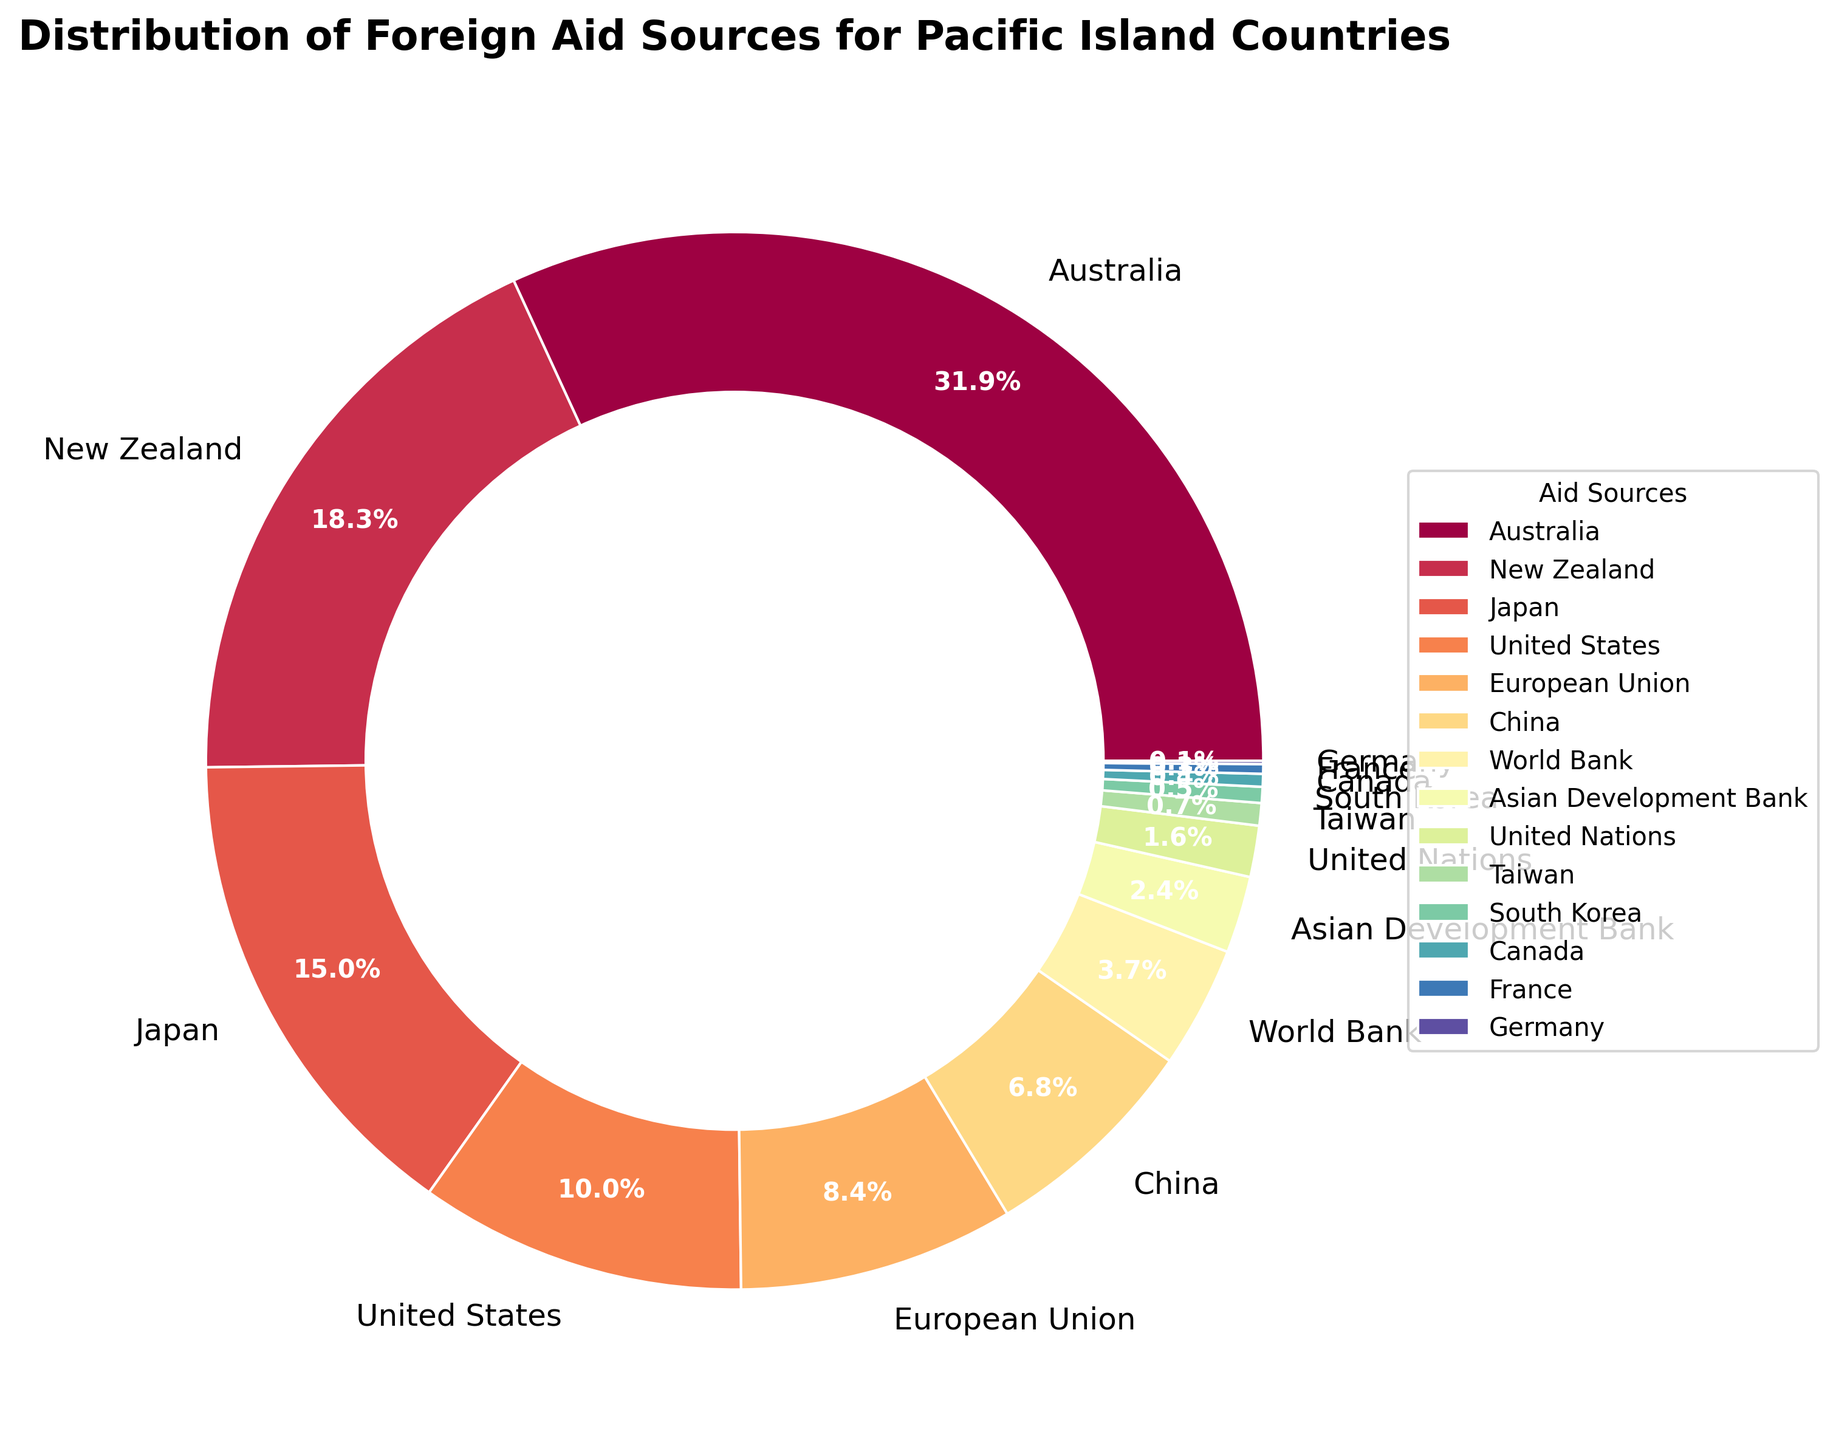Which is the largest contributor of foreign aid to Pacific Island countries? The largest contributor can be identified by finding the slice with the highest percentage value. In the pie chart, the slice labeled "Australia" has the highest percentage of 32.5%.
Answer: Australia What is the combined percentage of foreign aid from Australia and New Zealand? To find the combined percentage, add the percentage values of Australia and New Zealand. The percentages are 32.5% (Australia) and 18.7% (New Zealand). So, 32.5 + 18.7 = 51.2%.
Answer: 51.2% How does the percentage of aid from Japan compare to that from the United States? Compare the percentage values of Japan and the United States by subtracting one from the other. The percentages are 15.3% (Japan) and 10.2% (United States). So, 15.3 - 10.2 = 5.1%. Japan gives 5.1% more aid than the United States.
Answer: Japan gives 5.1% more aid Which country contributes the least to foreign aid among the listed sources? The country with the smallest slice in the pie chart should be identified. The smallest percentage is 0.1%, which belongs to Germany.
Answer: Germany What is the total percentage contribution from European countries (European Union, France, and Germany)? Sum the percentage values of the European Union, France, and Germany. The percentages are 8.6% (European Union), 0.3% (France), and 0.1% (Germany). So, 8.6 + 0.3 + 0.1 = 9.0%.
Answer: 9.0% Is the contribution from China greater than the combined contribution of Taiwan and South Korea? Compare the percentage of China with the sum of the percentages of Taiwan and South Korea. The percentages are 6.9% (China), 0.7% (Taiwan), and 0.5% (South Korea). Adding Taiwan and South Korea, 0.7 + 0.5 = 1.2%. China’s 6.9% is greater than 1.2%.
Answer: Yes How much more does the World Bank contribute compared to the Asian Development Bank? Find the difference between the percentages of the World Bank and the Asian Development Bank. The percentages are 3.8% (World Bank) and 2.4% (Asian Development Bank). So, 3.8 - 2.4 = 1.4%.
Answer: 1.4% What percentage of foreign aid is contributed by the United Nations? Identify the percentage value labeled with "United Nations" in the pie chart. The labeled percentage is 1.6%.
Answer: 1.6% Which three sources contribute the most to foreign aid, and what is their combined contribution? Identify the three largest slices in the pie chart: Australia (32.5%), New Zealand (18.7%), and Japan (15.3%). Sum their contributions: 32.5 + 18.7 + 15.3 = 66.5%.
Answer: Australia, New Zealand, Japan; 66.5% How does the contribution of the top three sources compare to the remaining sources? Calculate the total contribution of the top three sources (Australia, New Zealand, and Japan), which is 66.5%. Calculate the total of the remaining sources by subtracting this from 100%: 100 - 66.5 = 33.5%. The top three sources contribute 66.5% compared to the 33.5% from the remaining sources.
Answer: Top three: 66.5%, Remaining: 33.5% 